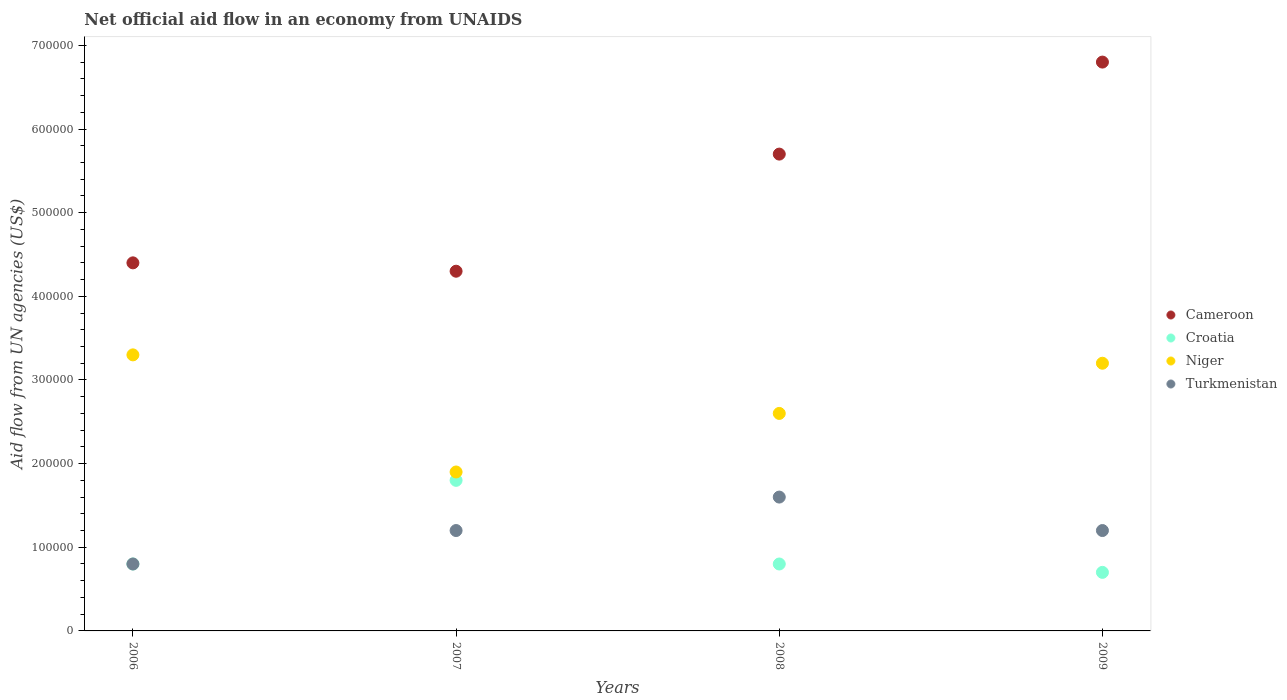How many different coloured dotlines are there?
Ensure brevity in your answer.  4. Is the number of dotlines equal to the number of legend labels?
Provide a short and direct response. Yes. What is the net official aid flow in Cameroon in 2007?
Provide a succinct answer. 4.30e+05. Across all years, what is the maximum net official aid flow in Turkmenistan?
Provide a succinct answer. 1.60e+05. Across all years, what is the minimum net official aid flow in Croatia?
Offer a very short reply. 7.00e+04. What is the total net official aid flow in Croatia in the graph?
Provide a succinct answer. 4.10e+05. What is the difference between the net official aid flow in Turkmenistan in 2009 and the net official aid flow in Croatia in 2008?
Your answer should be very brief. 4.00e+04. What is the average net official aid flow in Croatia per year?
Keep it short and to the point. 1.02e+05. In the year 2006, what is the difference between the net official aid flow in Croatia and net official aid flow in Niger?
Your response must be concise. -2.50e+05. In how many years, is the net official aid flow in Turkmenistan greater than 80000 US$?
Provide a succinct answer. 3. What is the ratio of the net official aid flow in Turkmenistan in 2008 to that in 2009?
Your answer should be very brief. 1.33. Is the difference between the net official aid flow in Croatia in 2007 and 2008 greater than the difference between the net official aid flow in Niger in 2007 and 2008?
Keep it short and to the point. Yes. What is the difference between the highest and the second highest net official aid flow in Niger?
Your answer should be very brief. 10000. What is the difference between the highest and the lowest net official aid flow in Niger?
Ensure brevity in your answer.  1.40e+05. In how many years, is the net official aid flow in Niger greater than the average net official aid flow in Niger taken over all years?
Give a very brief answer. 2. Is the sum of the net official aid flow in Niger in 2008 and 2009 greater than the maximum net official aid flow in Turkmenistan across all years?
Give a very brief answer. Yes. Does the net official aid flow in Croatia monotonically increase over the years?
Ensure brevity in your answer.  No. Is the net official aid flow in Niger strictly greater than the net official aid flow in Cameroon over the years?
Offer a terse response. No. How many dotlines are there?
Give a very brief answer. 4. How many years are there in the graph?
Provide a short and direct response. 4. Are the values on the major ticks of Y-axis written in scientific E-notation?
Give a very brief answer. No. Does the graph contain grids?
Offer a terse response. No. Where does the legend appear in the graph?
Give a very brief answer. Center right. How many legend labels are there?
Offer a terse response. 4. What is the title of the graph?
Give a very brief answer. Net official aid flow in an economy from UNAIDS. What is the label or title of the X-axis?
Offer a very short reply. Years. What is the label or title of the Y-axis?
Your answer should be very brief. Aid flow from UN agencies (US$). What is the Aid flow from UN agencies (US$) in Niger in 2006?
Make the answer very short. 3.30e+05. What is the Aid flow from UN agencies (US$) in Niger in 2007?
Give a very brief answer. 1.90e+05. What is the Aid flow from UN agencies (US$) of Cameroon in 2008?
Your response must be concise. 5.70e+05. What is the Aid flow from UN agencies (US$) in Croatia in 2008?
Your answer should be compact. 8.00e+04. What is the Aid flow from UN agencies (US$) in Cameroon in 2009?
Provide a short and direct response. 6.80e+05. What is the Aid flow from UN agencies (US$) of Croatia in 2009?
Provide a short and direct response. 7.00e+04. What is the Aid flow from UN agencies (US$) in Niger in 2009?
Ensure brevity in your answer.  3.20e+05. Across all years, what is the maximum Aid flow from UN agencies (US$) of Cameroon?
Make the answer very short. 6.80e+05. Across all years, what is the minimum Aid flow from UN agencies (US$) of Croatia?
Offer a terse response. 7.00e+04. Across all years, what is the minimum Aid flow from UN agencies (US$) of Turkmenistan?
Your answer should be compact. 8.00e+04. What is the total Aid flow from UN agencies (US$) in Cameroon in the graph?
Your answer should be compact. 2.12e+06. What is the total Aid flow from UN agencies (US$) in Croatia in the graph?
Offer a very short reply. 4.10e+05. What is the total Aid flow from UN agencies (US$) in Niger in the graph?
Offer a terse response. 1.10e+06. What is the difference between the Aid flow from UN agencies (US$) in Croatia in 2006 and that in 2007?
Give a very brief answer. -1.00e+05. What is the difference between the Aid flow from UN agencies (US$) in Turkmenistan in 2006 and that in 2007?
Keep it short and to the point. -4.00e+04. What is the difference between the Aid flow from UN agencies (US$) of Cameroon in 2006 and that in 2008?
Give a very brief answer. -1.30e+05. What is the difference between the Aid flow from UN agencies (US$) of Croatia in 2006 and that in 2008?
Provide a short and direct response. 0. What is the difference between the Aid flow from UN agencies (US$) in Niger in 2006 and that in 2008?
Your answer should be compact. 7.00e+04. What is the difference between the Aid flow from UN agencies (US$) in Turkmenistan in 2006 and that in 2008?
Keep it short and to the point. -8.00e+04. What is the difference between the Aid flow from UN agencies (US$) in Cameroon in 2006 and that in 2009?
Your answer should be compact. -2.40e+05. What is the difference between the Aid flow from UN agencies (US$) of Croatia in 2006 and that in 2009?
Make the answer very short. 10000. What is the difference between the Aid flow from UN agencies (US$) of Niger in 2006 and that in 2009?
Your answer should be compact. 10000. What is the difference between the Aid flow from UN agencies (US$) of Cameroon in 2007 and that in 2008?
Offer a very short reply. -1.40e+05. What is the difference between the Aid flow from UN agencies (US$) of Croatia in 2007 and that in 2008?
Provide a short and direct response. 1.00e+05. What is the difference between the Aid flow from UN agencies (US$) of Niger in 2007 and that in 2008?
Provide a succinct answer. -7.00e+04. What is the difference between the Aid flow from UN agencies (US$) of Turkmenistan in 2007 and that in 2008?
Keep it short and to the point. -4.00e+04. What is the difference between the Aid flow from UN agencies (US$) of Cameroon in 2007 and that in 2009?
Your answer should be very brief. -2.50e+05. What is the difference between the Aid flow from UN agencies (US$) of Turkmenistan in 2007 and that in 2009?
Ensure brevity in your answer.  0. What is the difference between the Aid flow from UN agencies (US$) in Cameroon in 2008 and that in 2009?
Your answer should be very brief. -1.10e+05. What is the difference between the Aid flow from UN agencies (US$) in Croatia in 2008 and that in 2009?
Give a very brief answer. 10000. What is the difference between the Aid flow from UN agencies (US$) in Niger in 2008 and that in 2009?
Provide a short and direct response. -6.00e+04. What is the difference between the Aid flow from UN agencies (US$) in Turkmenistan in 2008 and that in 2009?
Your answer should be very brief. 4.00e+04. What is the difference between the Aid flow from UN agencies (US$) of Cameroon in 2006 and the Aid flow from UN agencies (US$) of Niger in 2007?
Offer a very short reply. 2.50e+05. What is the difference between the Aid flow from UN agencies (US$) in Croatia in 2006 and the Aid flow from UN agencies (US$) in Turkmenistan in 2007?
Your response must be concise. -4.00e+04. What is the difference between the Aid flow from UN agencies (US$) of Cameroon in 2006 and the Aid flow from UN agencies (US$) of Croatia in 2008?
Keep it short and to the point. 3.60e+05. What is the difference between the Aid flow from UN agencies (US$) in Cameroon in 2006 and the Aid flow from UN agencies (US$) in Niger in 2008?
Your answer should be compact. 1.80e+05. What is the difference between the Aid flow from UN agencies (US$) of Croatia in 2006 and the Aid flow from UN agencies (US$) of Turkmenistan in 2008?
Offer a terse response. -8.00e+04. What is the difference between the Aid flow from UN agencies (US$) of Cameroon in 2006 and the Aid flow from UN agencies (US$) of Niger in 2009?
Ensure brevity in your answer.  1.20e+05. What is the difference between the Aid flow from UN agencies (US$) in Croatia in 2006 and the Aid flow from UN agencies (US$) in Niger in 2009?
Give a very brief answer. -2.40e+05. What is the difference between the Aid flow from UN agencies (US$) in Croatia in 2006 and the Aid flow from UN agencies (US$) in Turkmenistan in 2009?
Give a very brief answer. -4.00e+04. What is the difference between the Aid flow from UN agencies (US$) of Niger in 2006 and the Aid flow from UN agencies (US$) of Turkmenistan in 2009?
Offer a terse response. 2.10e+05. What is the difference between the Aid flow from UN agencies (US$) of Cameroon in 2007 and the Aid flow from UN agencies (US$) of Croatia in 2008?
Give a very brief answer. 3.50e+05. What is the difference between the Aid flow from UN agencies (US$) of Croatia in 2007 and the Aid flow from UN agencies (US$) of Niger in 2008?
Offer a terse response. -8.00e+04. What is the difference between the Aid flow from UN agencies (US$) of Croatia in 2007 and the Aid flow from UN agencies (US$) of Niger in 2009?
Your response must be concise. -1.40e+05. What is the difference between the Aid flow from UN agencies (US$) in Niger in 2007 and the Aid flow from UN agencies (US$) in Turkmenistan in 2009?
Offer a terse response. 7.00e+04. What is the difference between the Aid flow from UN agencies (US$) of Cameroon in 2008 and the Aid flow from UN agencies (US$) of Niger in 2009?
Your answer should be compact. 2.50e+05. What is the difference between the Aid flow from UN agencies (US$) of Croatia in 2008 and the Aid flow from UN agencies (US$) of Turkmenistan in 2009?
Offer a terse response. -4.00e+04. What is the average Aid flow from UN agencies (US$) of Cameroon per year?
Your response must be concise. 5.30e+05. What is the average Aid flow from UN agencies (US$) of Croatia per year?
Your answer should be very brief. 1.02e+05. What is the average Aid flow from UN agencies (US$) in Niger per year?
Your answer should be very brief. 2.75e+05. In the year 2006, what is the difference between the Aid flow from UN agencies (US$) in Cameroon and Aid flow from UN agencies (US$) in Croatia?
Offer a terse response. 3.60e+05. In the year 2006, what is the difference between the Aid flow from UN agencies (US$) in Croatia and Aid flow from UN agencies (US$) in Niger?
Provide a short and direct response. -2.50e+05. In the year 2007, what is the difference between the Aid flow from UN agencies (US$) in Croatia and Aid flow from UN agencies (US$) in Turkmenistan?
Offer a terse response. 6.00e+04. In the year 2007, what is the difference between the Aid flow from UN agencies (US$) in Niger and Aid flow from UN agencies (US$) in Turkmenistan?
Keep it short and to the point. 7.00e+04. In the year 2008, what is the difference between the Aid flow from UN agencies (US$) in Cameroon and Aid flow from UN agencies (US$) in Croatia?
Offer a terse response. 4.90e+05. In the year 2008, what is the difference between the Aid flow from UN agencies (US$) of Cameroon and Aid flow from UN agencies (US$) of Turkmenistan?
Your answer should be very brief. 4.10e+05. In the year 2008, what is the difference between the Aid flow from UN agencies (US$) of Croatia and Aid flow from UN agencies (US$) of Turkmenistan?
Your answer should be very brief. -8.00e+04. In the year 2009, what is the difference between the Aid flow from UN agencies (US$) of Cameroon and Aid flow from UN agencies (US$) of Turkmenistan?
Offer a very short reply. 5.60e+05. In the year 2009, what is the difference between the Aid flow from UN agencies (US$) of Niger and Aid flow from UN agencies (US$) of Turkmenistan?
Provide a short and direct response. 2.00e+05. What is the ratio of the Aid flow from UN agencies (US$) in Cameroon in 2006 to that in 2007?
Keep it short and to the point. 1.02. What is the ratio of the Aid flow from UN agencies (US$) of Croatia in 2006 to that in 2007?
Your answer should be compact. 0.44. What is the ratio of the Aid flow from UN agencies (US$) of Niger in 2006 to that in 2007?
Provide a short and direct response. 1.74. What is the ratio of the Aid flow from UN agencies (US$) of Turkmenistan in 2006 to that in 2007?
Ensure brevity in your answer.  0.67. What is the ratio of the Aid flow from UN agencies (US$) in Cameroon in 2006 to that in 2008?
Provide a short and direct response. 0.77. What is the ratio of the Aid flow from UN agencies (US$) in Croatia in 2006 to that in 2008?
Provide a succinct answer. 1. What is the ratio of the Aid flow from UN agencies (US$) in Niger in 2006 to that in 2008?
Your response must be concise. 1.27. What is the ratio of the Aid flow from UN agencies (US$) in Turkmenistan in 2006 to that in 2008?
Provide a short and direct response. 0.5. What is the ratio of the Aid flow from UN agencies (US$) in Cameroon in 2006 to that in 2009?
Your response must be concise. 0.65. What is the ratio of the Aid flow from UN agencies (US$) in Croatia in 2006 to that in 2009?
Offer a terse response. 1.14. What is the ratio of the Aid flow from UN agencies (US$) in Niger in 2006 to that in 2009?
Ensure brevity in your answer.  1.03. What is the ratio of the Aid flow from UN agencies (US$) of Cameroon in 2007 to that in 2008?
Make the answer very short. 0.75. What is the ratio of the Aid flow from UN agencies (US$) of Croatia in 2007 to that in 2008?
Offer a very short reply. 2.25. What is the ratio of the Aid flow from UN agencies (US$) of Niger in 2007 to that in 2008?
Keep it short and to the point. 0.73. What is the ratio of the Aid flow from UN agencies (US$) in Cameroon in 2007 to that in 2009?
Keep it short and to the point. 0.63. What is the ratio of the Aid flow from UN agencies (US$) of Croatia in 2007 to that in 2009?
Offer a very short reply. 2.57. What is the ratio of the Aid flow from UN agencies (US$) of Niger in 2007 to that in 2009?
Make the answer very short. 0.59. What is the ratio of the Aid flow from UN agencies (US$) in Cameroon in 2008 to that in 2009?
Your answer should be very brief. 0.84. What is the ratio of the Aid flow from UN agencies (US$) in Croatia in 2008 to that in 2009?
Give a very brief answer. 1.14. What is the ratio of the Aid flow from UN agencies (US$) in Niger in 2008 to that in 2009?
Your answer should be compact. 0.81. What is the difference between the highest and the second highest Aid flow from UN agencies (US$) of Cameroon?
Keep it short and to the point. 1.10e+05. What is the difference between the highest and the second highest Aid flow from UN agencies (US$) of Croatia?
Make the answer very short. 1.00e+05. What is the difference between the highest and the second highest Aid flow from UN agencies (US$) in Turkmenistan?
Provide a short and direct response. 4.00e+04. What is the difference between the highest and the lowest Aid flow from UN agencies (US$) in Cameroon?
Your answer should be compact. 2.50e+05. What is the difference between the highest and the lowest Aid flow from UN agencies (US$) of Niger?
Offer a terse response. 1.40e+05. What is the difference between the highest and the lowest Aid flow from UN agencies (US$) in Turkmenistan?
Your answer should be compact. 8.00e+04. 